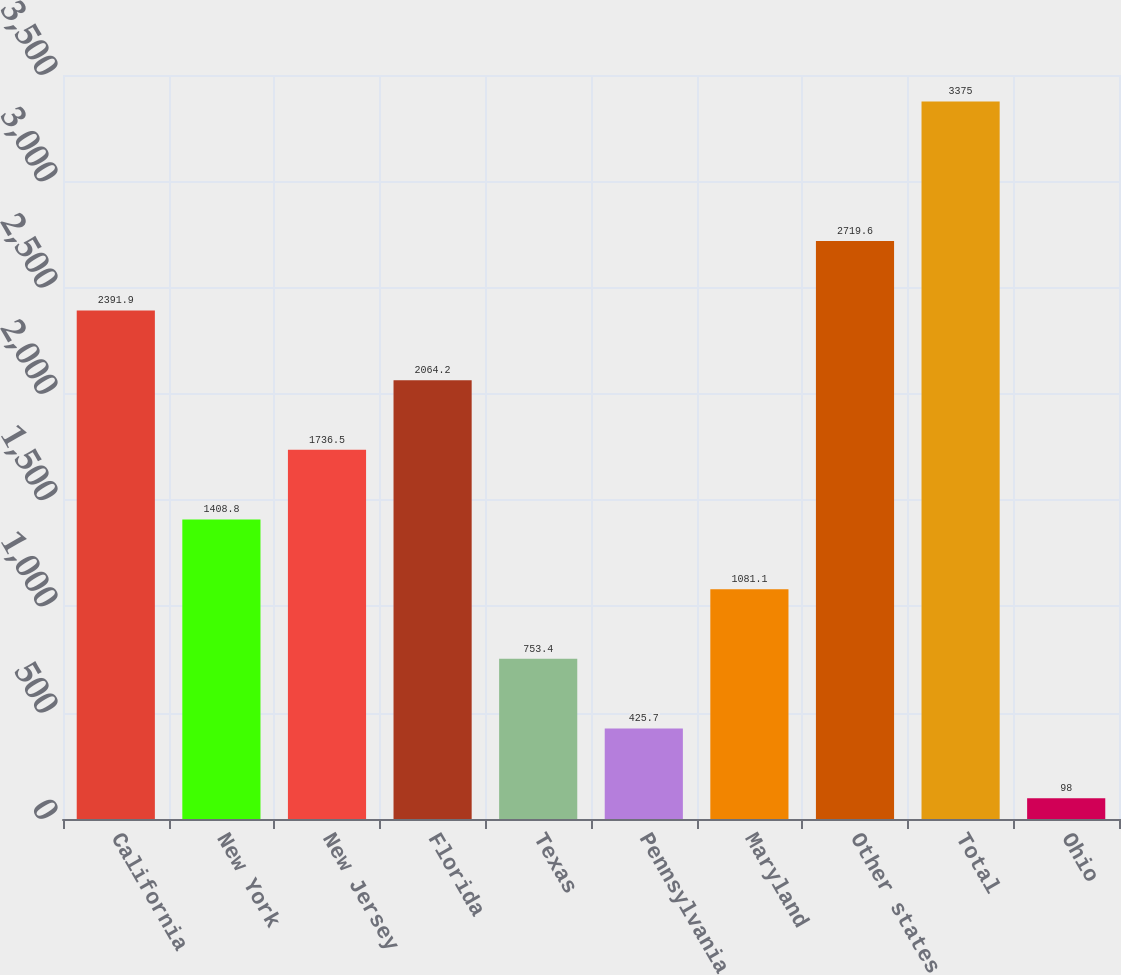<chart> <loc_0><loc_0><loc_500><loc_500><bar_chart><fcel>California<fcel>New York<fcel>New Jersey<fcel>Florida<fcel>Texas<fcel>Pennsylvania<fcel>Maryland<fcel>Other states<fcel>Total<fcel>Ohio<nl><fcel>2391.9<fcel>1408.8<fcel>1736.5<fcel>2064.2<fcel>753.4<fcel>425.7<fcel>1081.1<fcel>2719.6<fcel>3375<fcel>98<nl></chart> 